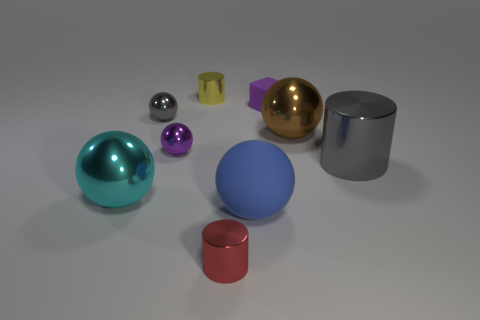Subtract all purple metal balls. How many balls are left? 4 Subtract all gray balls. How many balls are left? 4 Add 1 yellow things. How many objects exist? 10 Subtract all balls. How many objects are left? 4 Subtract 1 purple spheres. How many objects are left? 8 Subtract all green balls. Subtract all gray cylinders. How many balls are left? 5 Subtract all tiny gray things. Subtract all tiny yellow metal things. How many objects are left? 7 Add 1 small purple rubber things. How many small purple rubber things are left? 2 Add 9 tiny gray metal balls. How many tiny gray metal balls exist? 10 